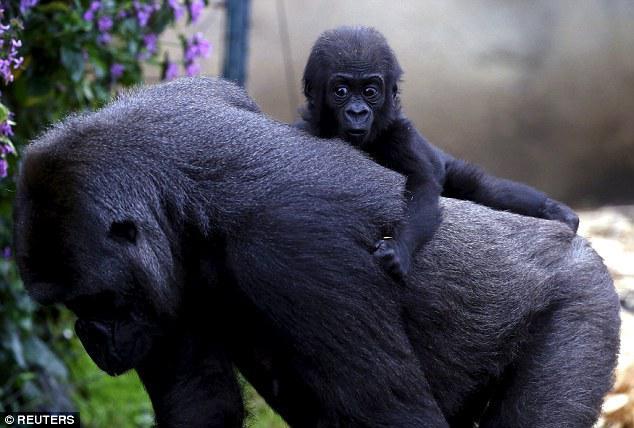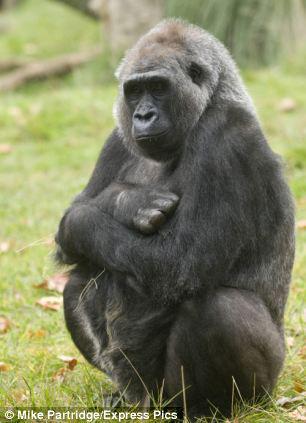The first image is the image on the left, the second image is the image on the right. Evaluate the accuracy of this statement regarding the images: "The left image shows a mother gorilla's bent arm around a baby gorilla held to her chest and her other arm held up to her face.". Is it true? Answer yes or no. No. The first image is the image on the left, the second image is the image on the right. Assess this claim about the two images: "A gorilla is holding a baby gorilla in its arms.". Correct or not? Answer yes or no. No. 